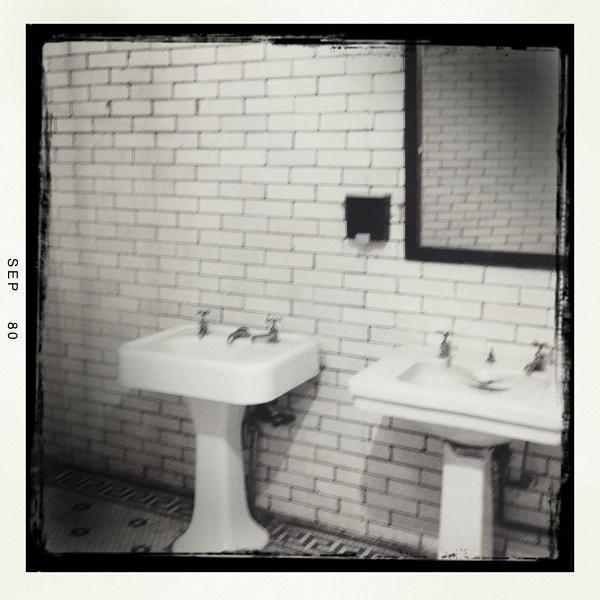How many sinks are there?
Give a very brief answer. 2. How many sinks are in the room?
Give a very brief answer. 2. How many sinks are visible?
Give a very brief answer. 2. 